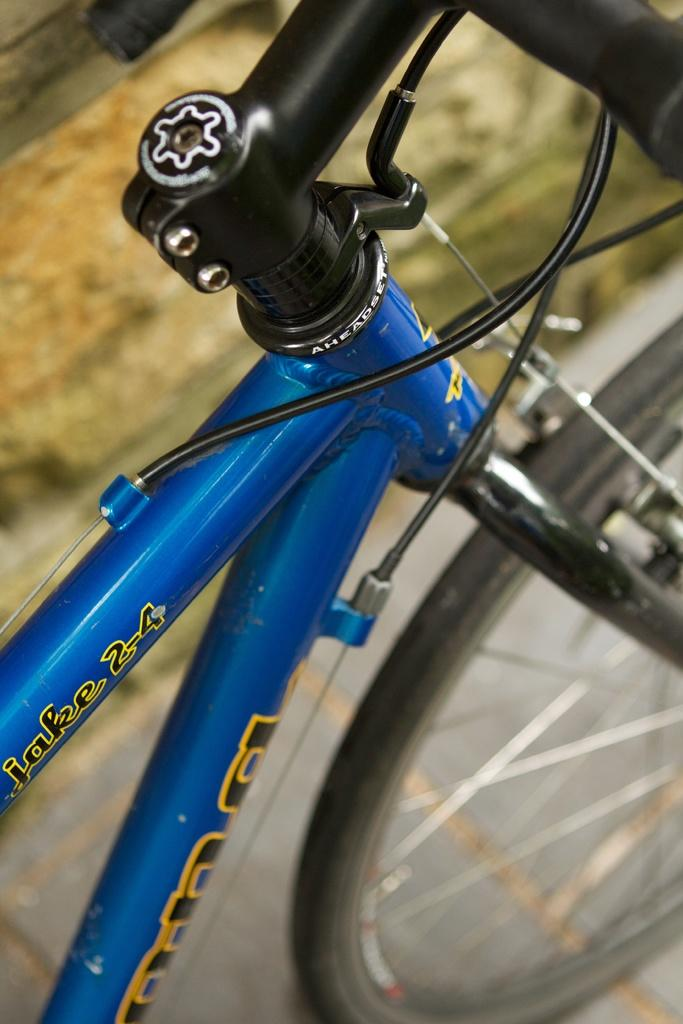Where was the image taken? The image is taken outdoors. What can be seen in the image besides the outdoor setting? There is a bicycle in the image. How is the bicycle positioned in the image? The bicycle is parked on the road. What type of juice is being served on the tray in the image? There is no tray or juice present in the image. What is the engine type of the bicycle in the image? The image does not provide information about the engine type of the bicycle, as bicycles typically do not have engines. 